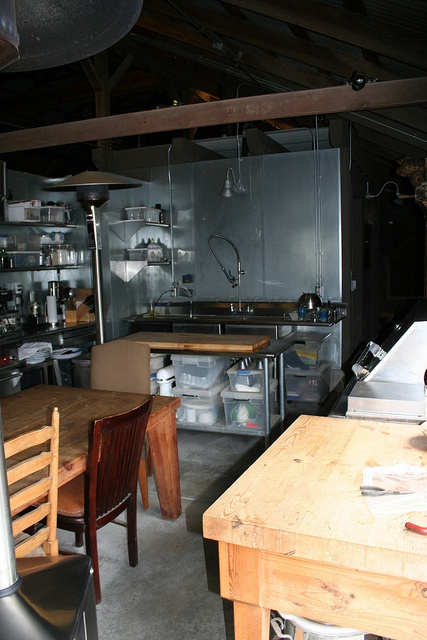Describe the objects in this image and their specific colors. I can see dining table in black, beige, tan, and darkgray tones, chair in black, maroon, brown, and darkgray tones, dining table in black, maroon, and brown tones, chair in black, tan, gray, and maroon tones, and chair in black, gray, and maroon tones in this image. 